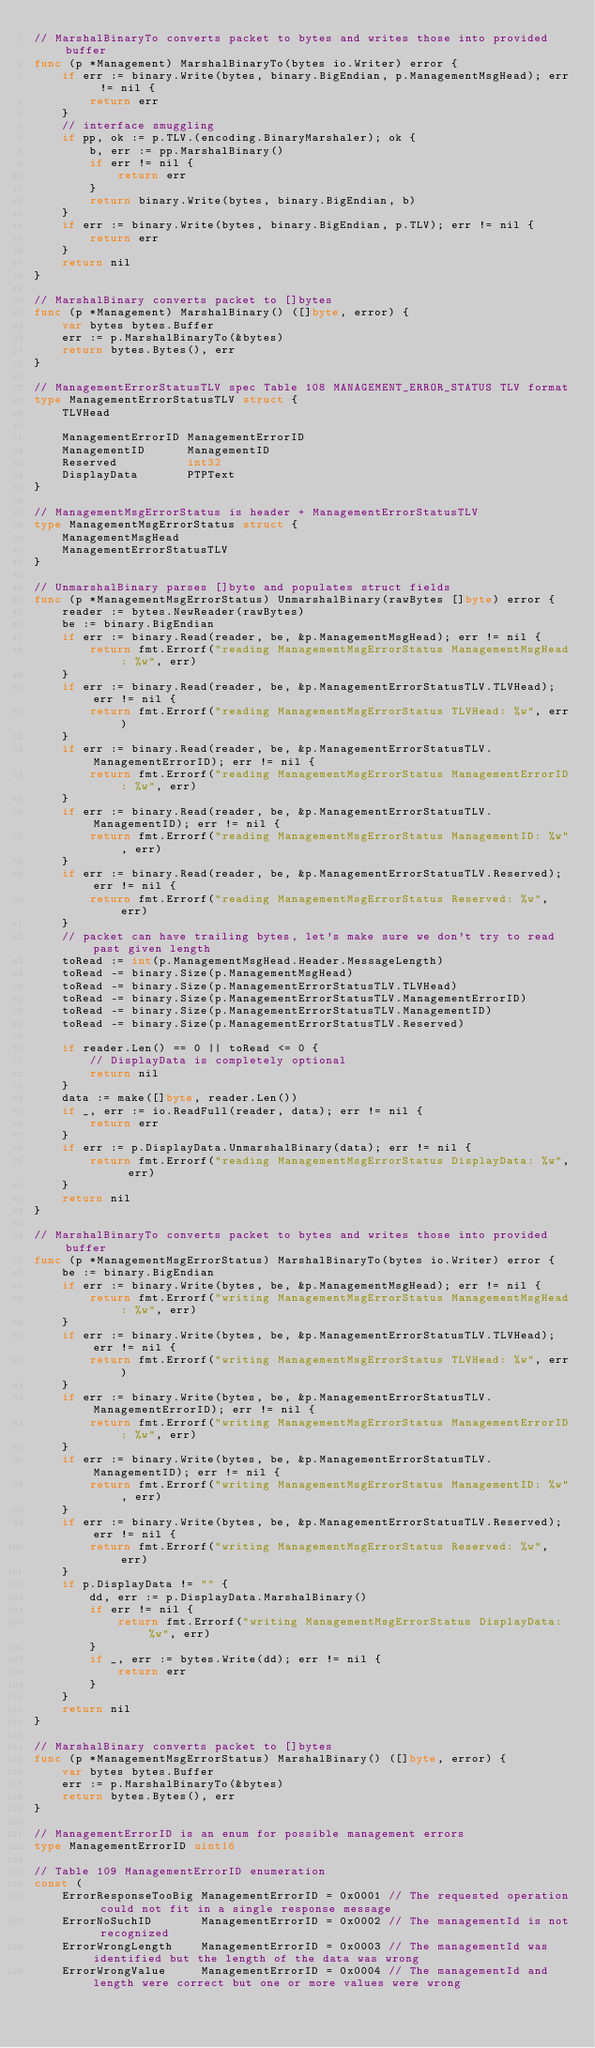Convert code to text. <code><loc_0><loc_0><loc_500><loc_500><_Go_>// MarshalBinaryTo converts packet to bytes and writes those into provided buffer
func (p *Management) MarshalBinaryTo(bytes io.Writer) error {
	if err := binary.Write(bytes, binary.BigEndian, p.ManagementMsgHead); err != nil {
		return err
	}
	// interface smuggling
	if pp, ok := p.TLV.(encoding.BinaryMarshaler); ok {
		b, err := pp.MarshalBinary()
		if err != nil {
			return err
		}
		return binary.Write(bytes, binary.BigEndian, b)
	}
	if err := binary.Write(bytes, binary.BigEndian, p.TLV); err != nil {
		return err
	}
	return nil
}

// MarshalBinary converts packet to []bytes
func (p *Management) MarshalBinary() ([]byte, error) {
	var bytes bytes.Buffer
	err := p.MarshalBinaryTo(&bytes)
	return bytes.Bytes(), err
}

// ManagementErrorStatusTLV spec Table 108 MANAGEMENT_ERROR_STATUS TLV format
type ManagementErrorStatusTLV struct {
	TLVHead

	ManagementErrorID ManagementErrorID
	ManagementID      ManagementID
	Reserved          int32
	DisplayData       PTPText
}

// ManagementMsgErrorStatus is header + ManagementErrorStatusTLV
type ManagementMsgErrorStatus struct {
	ManagementMsgHead
	ManagementErrorStatusTLV
}

// UnmarshalBinary parses []byte and populates struct fields
func (p *ManagementMsgErrorStatus) UnmarshalBinary(rawBytes []byte) error {
	reader := bytes.NewReader(rawBytes)
	be := binary.BigEndian
	if err := binary.Read(reader, be, &p.ManagementMsgHead); err != nil {
		return fmt.Errorf("reading ManagementMsgErrorStatus ManagementMsgHead: %w", err)
	}
	if err := binary.Read(reader, be, &p.ManagementErrorStatusTLV.TLVHead); err != nil {
		return fmt.Errorf("reading ManagementMsgErrorStatus TLVHead: %w", err)
	}
	if err := binary.Read(reader, be, &p.ManagementErrorStatusTLV.ManagementErrorID); err != nil {
		return fmt.Errorf("reading ManagementMsgErrorStatus ManagementErrorID: %w", err)
	}
	if err := binary.Read(reader, be, &p.ManagementErrorStatusTLV.ManagementID); err != nil {
		return fmt.Errorf("reading ManagementMsgErrorStatus ManagementID: %w", err)
	}
	if err := binary.Read(reader, be, &p.ManagementErrorStatusTLV.Reserved); err != nil {
		return fmt.Errorf("reading ManagementMsgErrorStatus Reserved: %w", err)
	}
	// packet can have trailing bytes, let's make sure we don't try to read past given length
	toRead := int(p.ManagementMsgHead.Header.MessageLength)
	toRead -= binary.Size(p.ManagementMsgHead)
	toRead -= binary.Size(p.ManagementErrorStatusTLV.TLVHead)
	toRead -= binary.Size(p.ManagementErrorStatusTLV.ManagementErrorID)
	toRead -= binary.Size(p.ManagementErrorStatusTLV.ManagementID)
	toRead -= binary.Size(p.ManagementErrorStatusTLV.Reserved)

	if reader.Len() == 0 || toRead <= 0 {
		// DisplayData is completely optional
		return nil
	}
	data := make([]byte, reader.Len())
	if _, err := io.ReadFull(reader, data); err != nil {
		return err
	}
	if err := p.DisplayData.UnmarshalBinary(data); err != nil {
		return fmt.Errorf("reading ManagementMsgErrorStatus DisplayData: %w", err)
	}
	return nil
}

// MarshalBinaryTo converts packet to bytes and writes those into provided buffer
func (p *ManagementMsgErrorStatus) MarshalBinaryTo(bytes io.Writer) error {
	be := binary.BigEndian
	if err := binary.Write(bytes, be, &p.ManagementMsgHead); err != nil {
		return fmt.Errorf("writing ManagementMsgErrorStatus ManagementMsgHead: %w", err)
	}
	if err := binary.Write(bytes, be, &p.ManagementErrorStatusTLV.TLVHead); err != nil {
		return fmt.Errorf("writing ManagementMsgErrorStatus TLVHead: %w", err)
	}
	if err := binary.Write(bytes, be, &p.ManagementErrorStatusTLV.ManagementErrorID); err != nil {
		return fmt.Errorf("writing ManagementMsgErrorStatus ManagementErrorID: %w", err)
	}
	if err := binary.Write(bytes, be, &p.ManagementErrorStatusTLV.ManagementID); err != nil {
		return fmt.Errorf("writing ManagementMsgErrorStatus ManagementID: %w", err)
	}
	if err := binary.Write(bytes, be, &p.ManagementErrorStatusTLV.Reserved); err != nil {
		return fmt.Errorf("writing ManagementMsgErrorStatus Reserved: %w", err)
	}
	if p.DisplayData != "" {
		dd, err := p.DisplayData.MarshalBinary()
		if err != nil {
			return fmt.Errorf("writing ManagementMsgErrorStatus DisplayData: %w", err)
		}
		if _, err := bytes.Write(dd); err != nil {
			return err
		}
	}
	return nil
}

// MarshalBinary converts packet to []bytes
func (p *ManagementMsgErrorStatus) MarshalBinary() ([]byte, error) {
	var bytes bytes.Buffer
	err := p.MarshalBinaryTo(&bytes)
	return bytes.Bytes(), err
}

// ManagementErrorID is an enum for possible management errors
type ManagementErrorID uint16

// Table 109 ManagementErrorID enumeration
const (
	ErrorResponseTooBig ManagementErrorID = 0x0001 // The requested operation could not fit in a single response message
	ErrorNoSuchID       ManagementErrorID = 0x0002 // The managementId is not recognized
	ErrorWrongLength    ManagementErrorID = 0x0003 // The managementId was identified but the length of the data was wrong
	ErrorWrongValue     ManagementErrorID = 0x0004 // The managementId and length were correct but one or more values were wrong</code> 